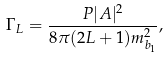Convert formula to latex. <formula><loc_0><loc_0><loc_500><loc_500>\Gamma _ { L } = \frac { P | A | ^ { 2 } } { 8 \pi ( 2 L + 1 ) m _ { b _ { 1 } } ^ { 2 } } ,</formula> 